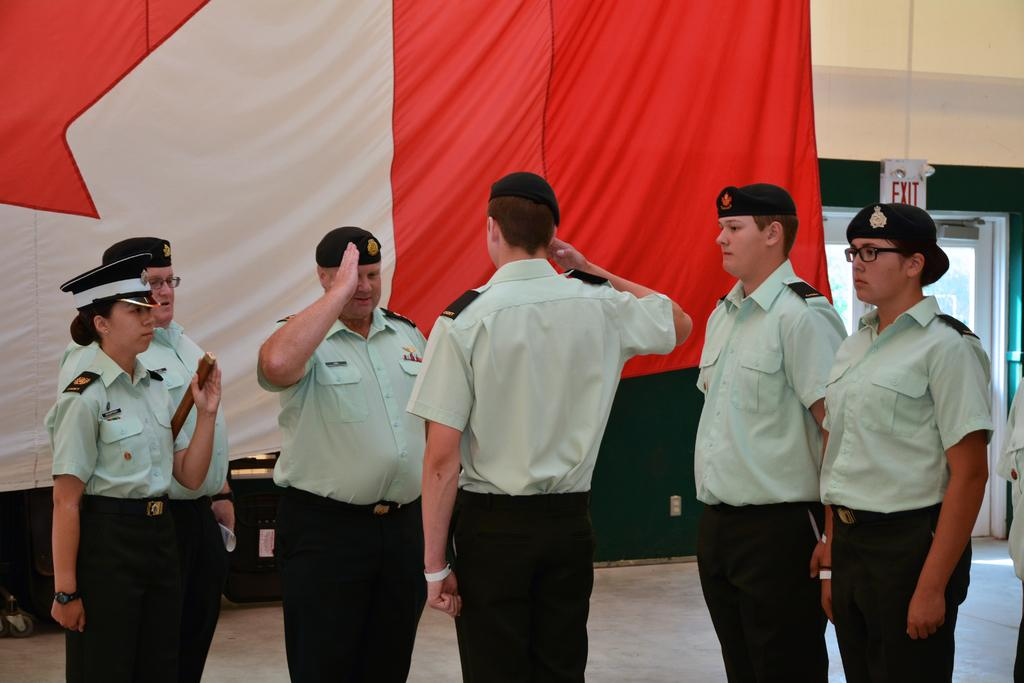Who or what can be seen in the image? There are people in the image. What is the flag associated with in the image? There is a flag in the image. What type of structure is visible in the image? There is a building in the image. What type of cushion is being used by the people in the image? There is no mention of a cushion in the image, so it cannot be determined if one is present or being used. 